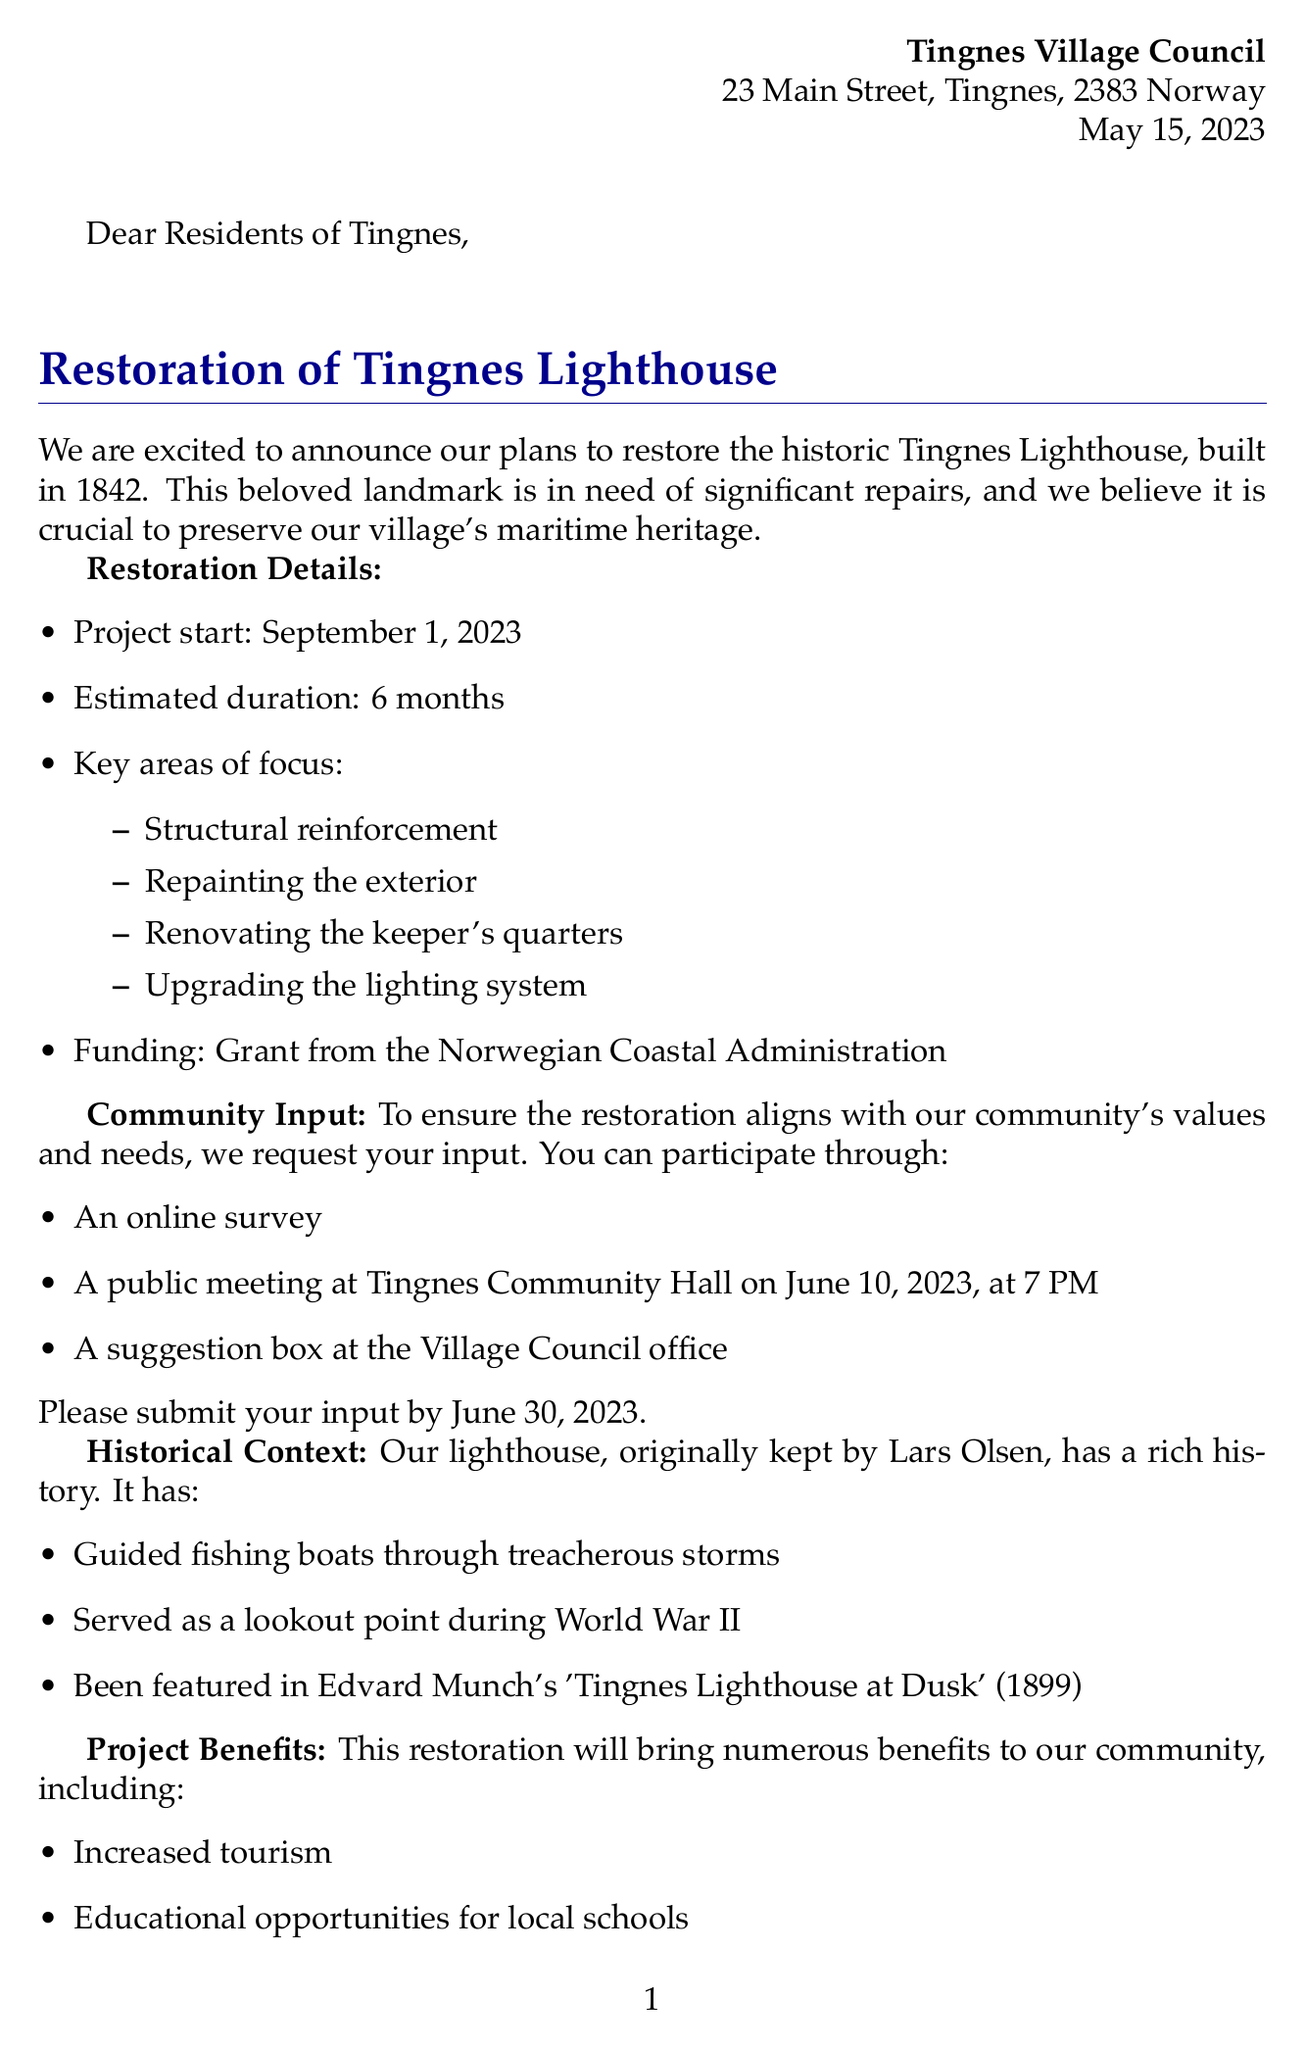what is the date of the letter? The letter was dated May 15, 2023.
Answer: May 15, 2023 what is the age of the Tingnes Lighthouse? The lighthouse was built in 1842, and this year is 2023, so it is 181 years old.
Answer: 181 years when is the project scheduled to start? The project start date is mentioned in the letter as September 1, 2023.
Answer: September 1, 2023 who is the contact person for the project? The letter states the contact person as Ingrid Larsen, Project Coordinator.
Answer: Ingrid Larsen what are the key areas of focus in the restoration? The letter lists structural reinforcement, repainting the exterior, renovating the keeper's quarters, and upgrading the lighting system as key areas.
Answer: structural reinforcement, repainting the exterior, renovating the keeper's quarters, upgrading the lighting system why is community input important? The document mentions that input is needed to ensure the restoration aligns with community values and needs.
Answer: to ensure alignment with community values and needs what was the original keeper's name? The letter states that Lars Olsen was the original keeper of the lighthouse.
Answer: Lars Olsen when is the public meeting scheduled? The letter specifies the public meeting will be held on June 10, 2023, at 7 PM.
Answer: June 10, 2023, at 7 PM what is one benefit of the restoration project? The letter highlights increased tourism as one of the benefits of the restoration project.
Answer: increased tourism 